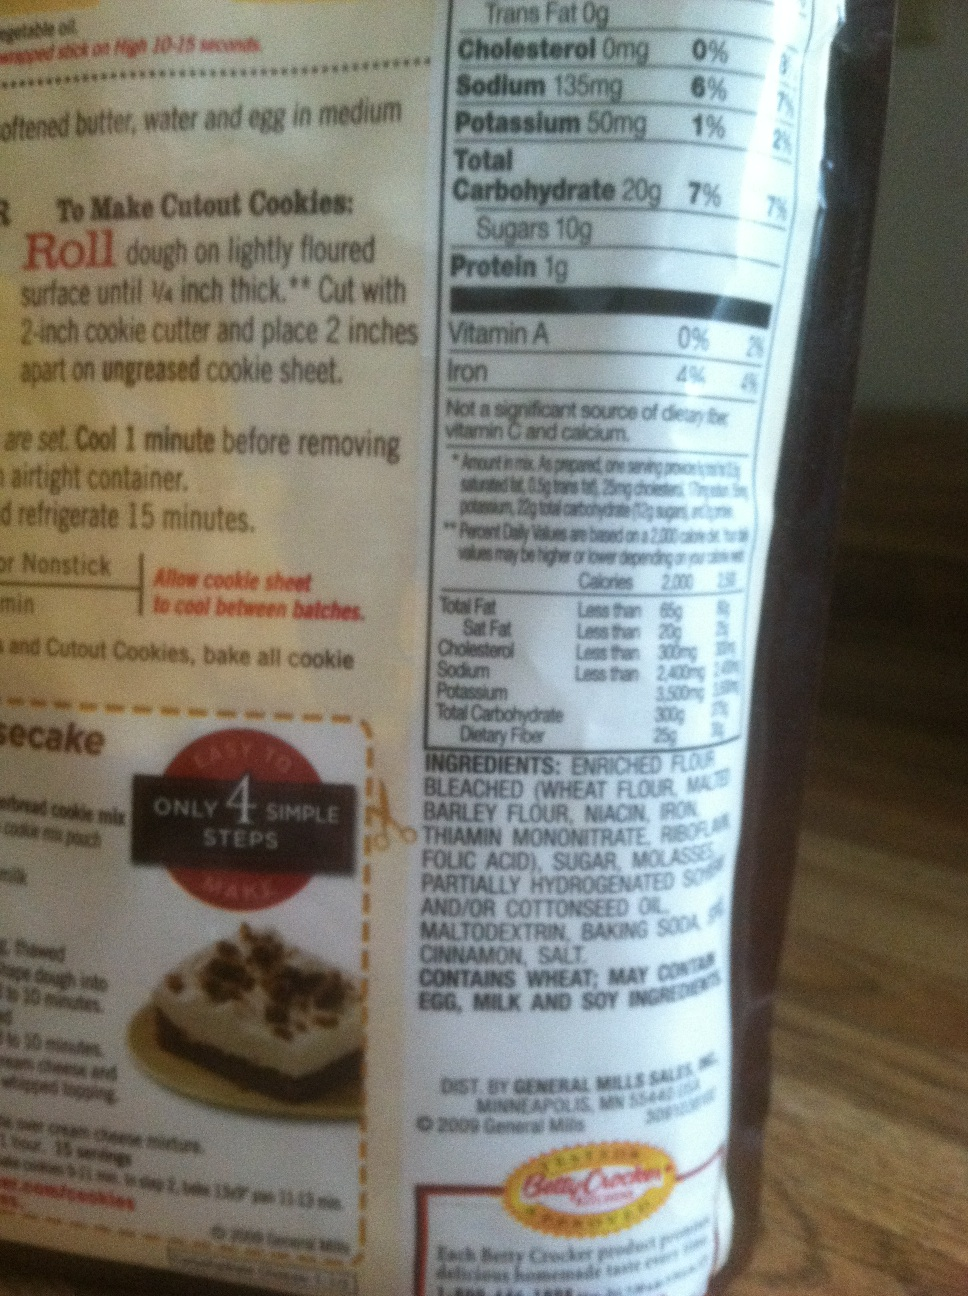Imagine you're hosting a cookie baking party using this mix. What kind of activities and decorations would you plan? For a cookie baking party, the decor would be cozy and festive. We'd have a table set with colorful cookie cutters, rolling pins, and a variety of toppings like sprinkles, chocolate chips, and icing. Each participant would have a personalized apron. Activities would include a cookie decorating contest, tasting different cookie recipes, and a storytelling session where everyone shares their favorite baking memories. 